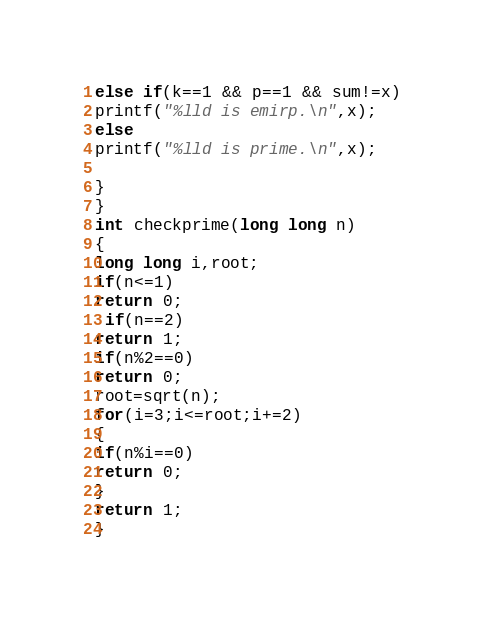Convert code to text. <code><loc_0><loc_0><loc_500><loc_500><_C++_>else if(k==1 && p==1 && sum!=x)
printf("%lld is emirp.\n",x);
else
printf("%lld is prime.\n",x);

}
}
int checkprime(long long n)
{
long long i,root;
if(n<=1)
return 0;
 if(n==2)
return 1;
if(n%2==0)
return 0;
root=sqrt(n);
for(i=3;i<=root;i+=2)
{
if(n%i==0)
return 0;
}
return 1;
}
</code> 